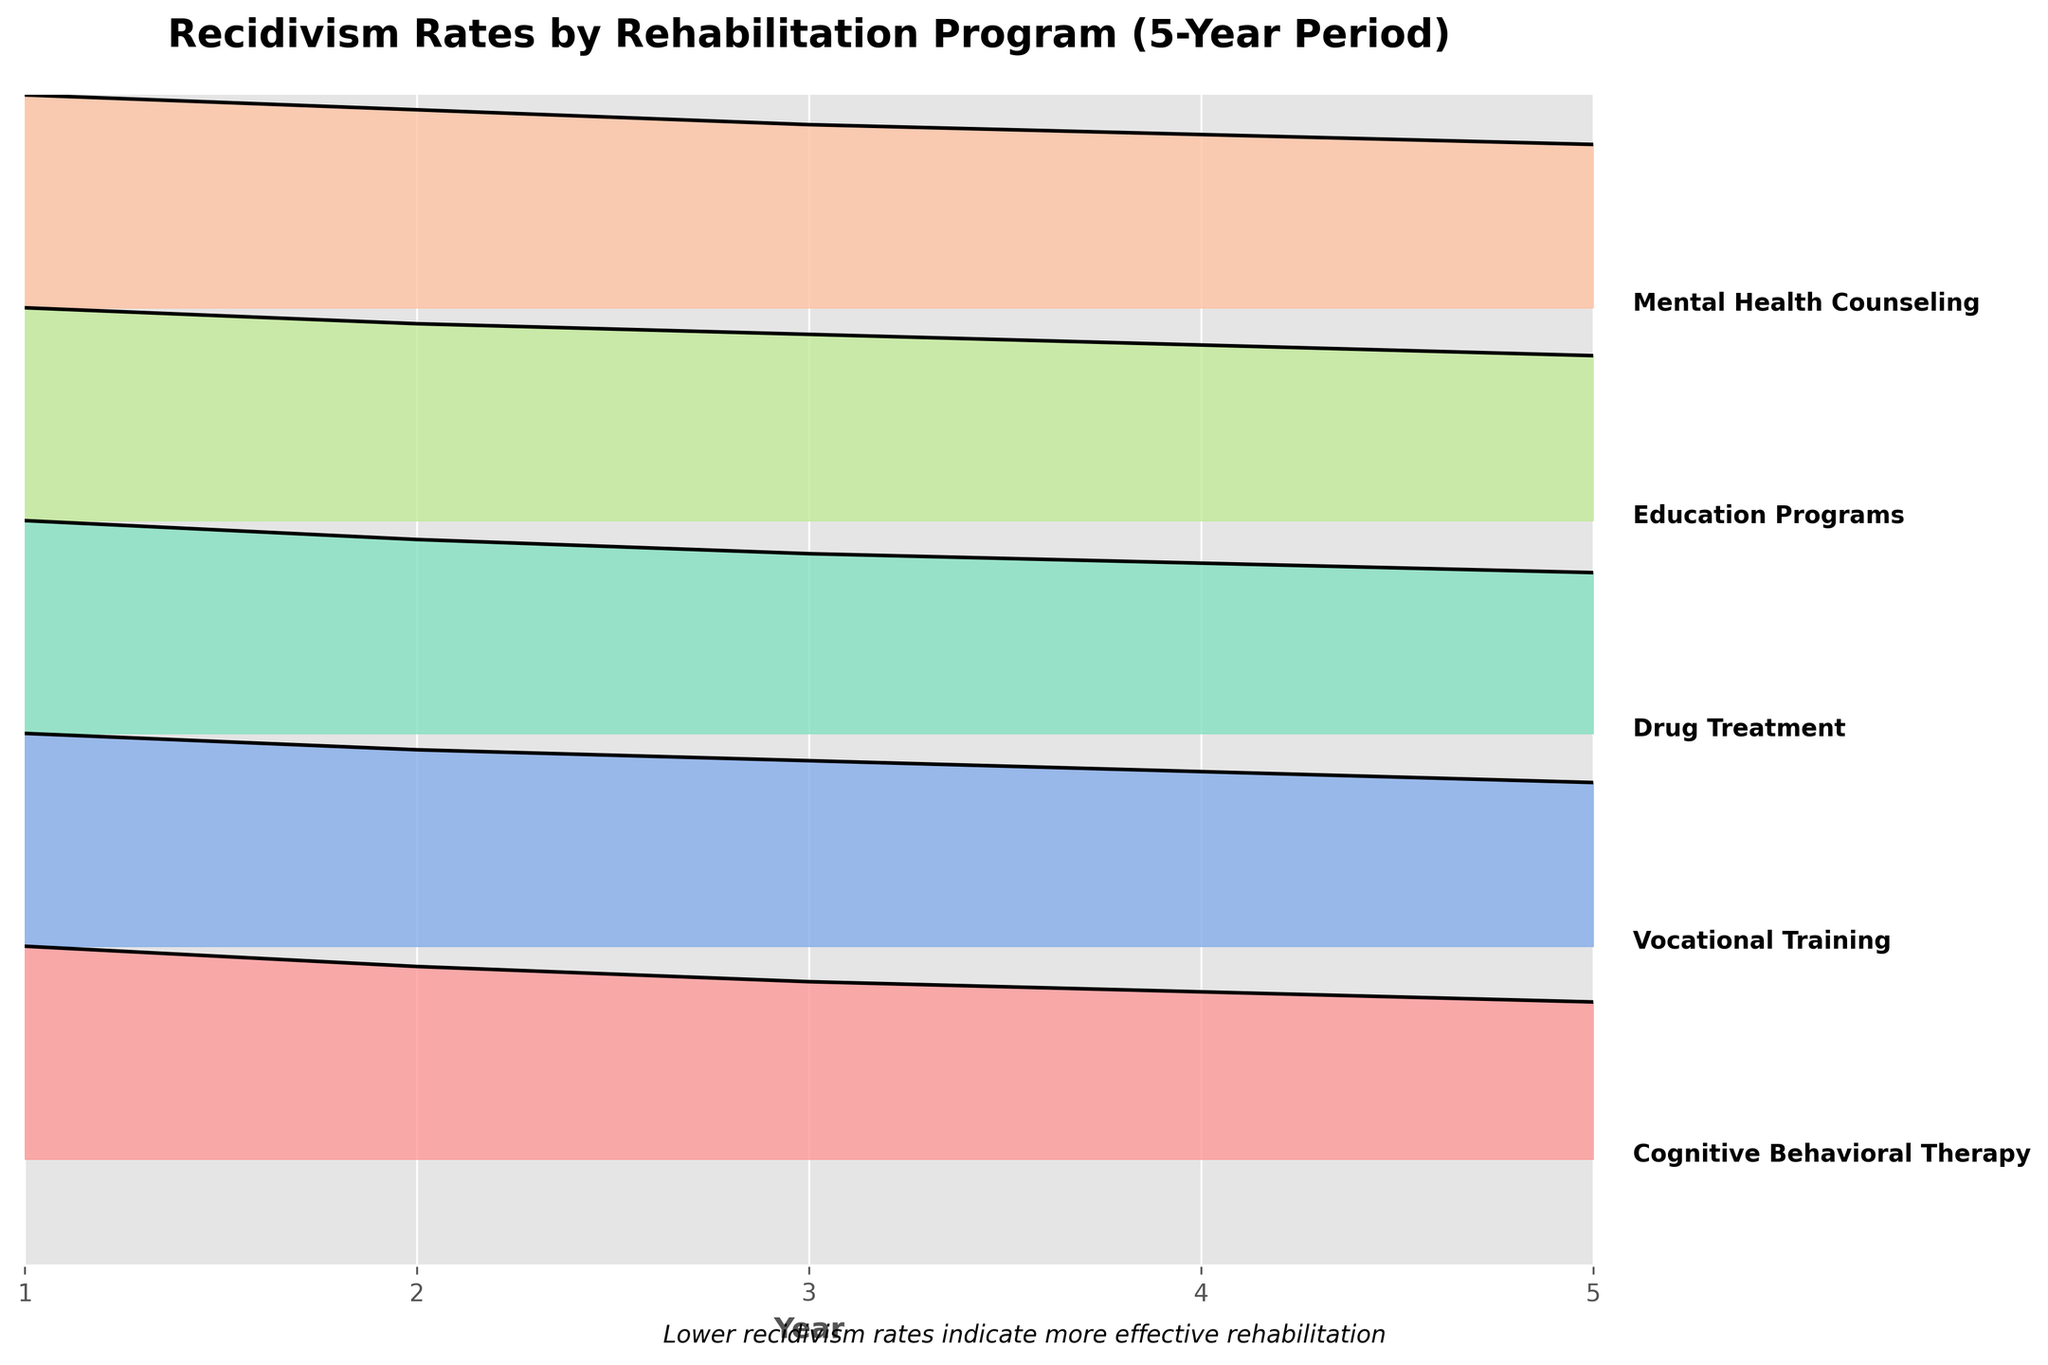What is the title of the plot? The title of the plot is located at the top of the figure. It reads 'Recidivism Rates by Rehabilitation Program (5-Year Period)'.
Answer: Recidivism Rates by Rehabilitation Program (5-Year Period) What are the labels on the x-axis? The labels on the x-axis represent the years over a 5-year period. They are listed as 1, 2, 3, 4, and 5.
Answer: 1, 2, 3, 4, 5 Which rehabilitation program starts with the highest recidivism rate in Year 1? By examining the height of the filled areas at Year 1, we see that Drug Treatment has the highest starting recidivism rate.
Answer: Drug Treatment Which program has the lowest recidivism rate at Year 5? By checking the values at the Year 5 positions, Vocational Training has the lowest recidivism rate.
Answer: Vocational Training How many rehabilitation programs are compared in the plot? The plot shows multiple ridgelines with labeled programs. Counting these labels gives a total of 5 programs.
Answer: 5 What trend can be observed for Cognitive Behavioral Therapy from Year 1 to Year 5? The plot indicates a downward trend in the recidivism rate for Cognitive Behavioral Therapy from Year 1 to Year 5.
Answer: Downward trend Compare the recidivism rates of Education Programs and Mental Health Counseling in Year 3. Which is lower? By comparing the heights of the filled areas for both programs at Year 3, Education Programs has a lower recidivism rate than Mental Health Counseling.
Answer: Education Programs Which program shows the largest decrease in recidivism rate from Year 1 to Year 5? To determine this, calculate the difference between Year 1 and Year 5 rates for all programs. Drug Treatment decreases from 0.45 to 0.34, the largest drop of 0.11.
Answer: Drug Treatment What is a common observation about the recidivism rates of all programs over the 5-year period? Inspecting all ridgeline plots, we notice that all programs show a general downward trend in recidivism rates over the 5 years.
Answer: Downward trend How does the recidivism rate of Vocational Training in Year 4 compare to Mental Health Counseling in Year 4? Comparing the heights of the filled areas at Year 4, Vocational Training's recidivism rate is lower than that of Mental Health Counseling.
Answer: Vocational Training 